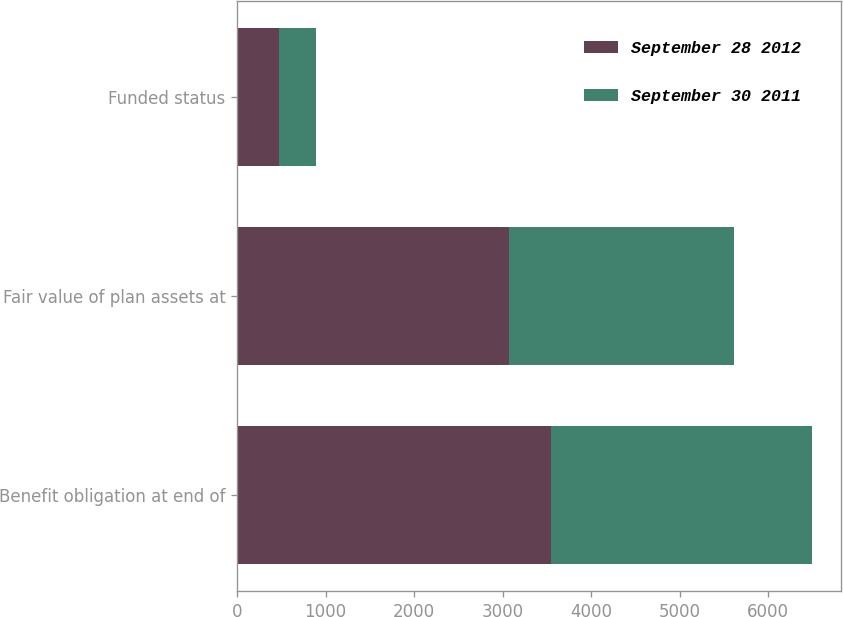Convert chart to OTSL. <chart><loc_0><loc_0><loc_500><loc_500><stacked_bar_chart><ecel><fcel>Benefit obligation at end of<fcel>Fair value of plan assets at<fcel>Funded status<nl><fcel>September 28 2012<fcel>3546<fcel>3077<fcel>469<nl><fcel>September 30 2011<fcel>2955<fcel>2536<fcel>419<nl></chart> 